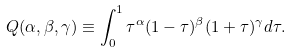Convert formula to latex. <formula><loc_0><loc_0><loc_500><loc_500>Q ( \alpha , \beta , \gamma ) \equiv \int _ { 0 } ^ { 1 } \tau ^ { \alpha } ( 1 - \tau ) ^ { \beta } ( 1 + \tau ) ^ { \gamma } d \tau .</formula> 